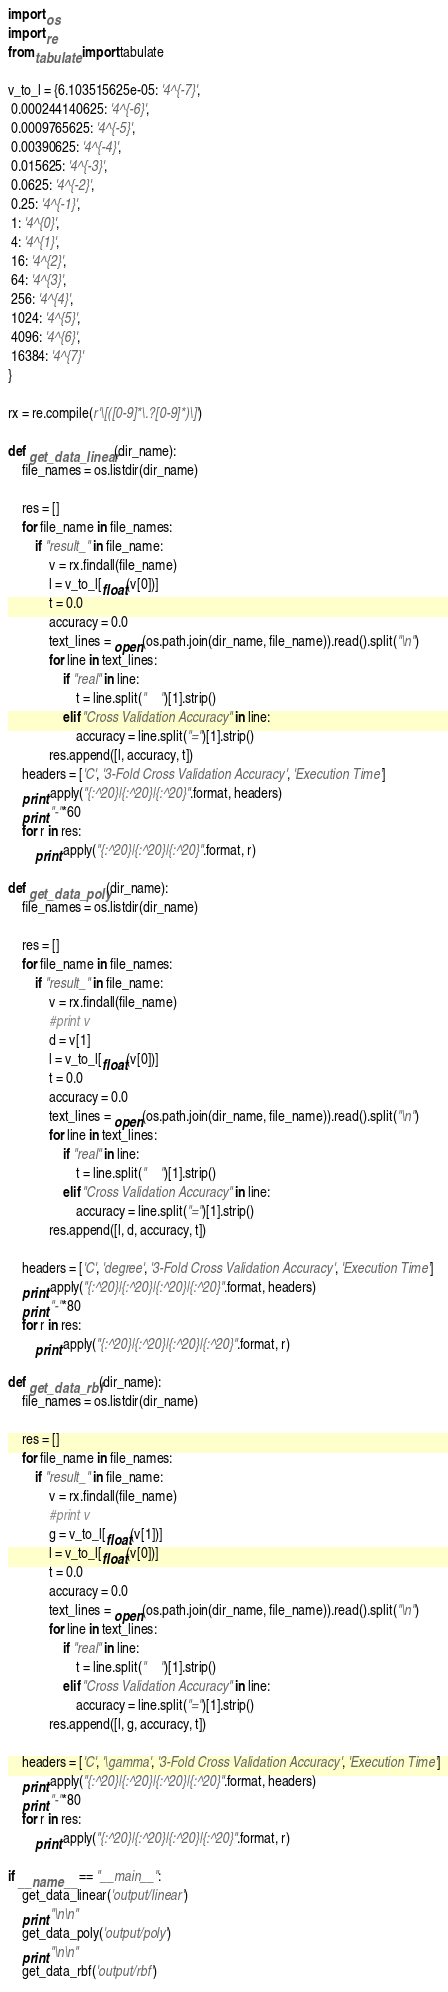<code> <loc_0><loc_0><loc_500><loc_500><_Python_>import os
import re
from tabulate import tabulate

v_to_l = {6.103515625e-05: '4^{-7}',
 0.000244140625: '4^{-6}',
 0.0009765625: '4^{-5}',
 0.00390625: '4^{-4}',
 0.015625: '4^{-3}',
 0.0625: '4^{-2}',
 0.25: '4^{-1}',
 1: '4^{0}',
 4: '4^{1}',
 16: '4^{2}',
 64: '4^{3}',
 256: '4^{4}',
 1024: '4^{5}',
 4096: '4^{6}',
 16384: '4^{7}'
}

rx = re.compile(r'\[([0-9]*\.?[0-9]*)\]')

def get_data_linear(dir_name):
    file_names = os.listdir(dir_name)
    
    res = []
    for file_name in file_names:
        if "result_" in file_name:
            v = rx.findall(file_name)
            l = v_to_l[float(v[0])]
            t = 0.0
            accuracy = 0.0
            text_lines = open(os.path.join(dir_name, file_name)).read().split("\n")
            for line in text_lines:
                if "real" in line:
                    t = line.split("	")[1].strip()
                elif "Cross Validation Accuracy" in line:
                    accuracy = line.split("=")[1].strip()
            res.append([l, accuracy, t])
    headers = ['C', '3-Fold Cross Validation Accuracy', 'Execution Time']
    print apply("{:^20}|{:^20}|{:^20}".format, headers)
    print "-"*60
    for r in res:
        print apply("{:^20}|{:^20}|{:^20}".format, r)

def get_data_poly(dir_name):
    file_names = os.listdir(dir_name)
    
    res = []
    for file_name in file_names:
        if "result_" in file_name:
            v = rx.findall(file_name)
            #print v
            d = v[1]
            l = v_to_l[float(v[0])]
            t = 0.0
            accuracy = 0.0
            text_lines = open(os.path.join(dir_name, file_name)).read().split("\n")
            for line in text_lines:
                if "real" in line:
                    t = line.split("	")[1].strip()
                elif "Cross Validation Accuracy" in line:
                    accuracy = line.split("=")[1].strip()
            res.append([l, d, accuracy, t])
    
    headers = ['C', 'degree', '3-Fold Cross Validation Accuracy', 'Execution Time']
    print apply("{:^20}|{:^20}|{:^20}|{:^20}".format, headers)
    print "-"*80
    for r in res:
        print apply("{:^20}|{:^20}|{:^20}|{:^20}".format, r)

def get_data_rbf(dir_name):
    file_names = os.listdir(dir_name)
    
    res = []
    for file_name in file_names:
        if "result_" in file_name:
            v = rx.findall(file_name)
            #print v
            g = v_to_l[float(v[1])]
            l = v_to_l[float(v[0])]
            t = 0.0
            accuracy = 0.0
            text_lines = open(os.path.join(dir_name, file_name)).read().split("\n")
            for line in text_lines:
                if "real" in line:
                    t = line.split("	")[1].strip()
                elif "Cross Validation Accuracy" in line:
                    accuracy = line.split("=")[1].strip()
            res.append([l, g, accuracy, t])
    
    headers = ['C', '\gamma', '3-Fold Cross Validation Accuracy', 'Execution Time']
    print apply("{:^20}|{:^20}|{:^20}|{:^20}".format, headers)
    print "-"*80
    for r in res:
        print apply("{:^20}|{:^20}|{:^20}|{:^20}".format, r)

if __name__ == "__main__":
    get_data_linear('output/linear')
    print "\n\n"
    get_data_poly('output/poly')
    print "\n\n"
    get_data_rbf('output/rbf')
</code> 